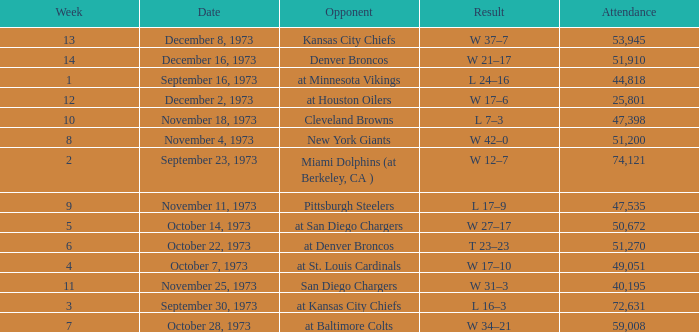Parse the full table. {'header': ['Week', 'Date', 'Opponent', 'Result', 'Attendance'], 'rows': [['13', 'December 8, 1973', 'Kansas City Chiefs', 'W 37–7', '53,945'], ['14', 'December 16, 1973', 'Denver Broncos', 'W 21–17', '51,910'], ['1', 'September 16, 1973', 'at Minnesota Vikings', 'L 24–16', '44,818'], ['12', 'December 2, 1973', 'at Houston Oilers', 'W 17–6', '25,801'], ['10', 'November 18, 1973', 'Cleveland Browns', 'L 7–3', '47,398'], ['8', 'November 4, 1973', 'New York Giants', 'W 42–0', '51,200'], ['2', 'September 23, 1973', 'Miami Dolphins (at Berkeley, CA )', 'W 12–7', '74,121'], ['9', 'November 11, 1973', 'Pittsburgh Steelers', 'L 17–9', '47,535'], ['5', 'October 14, 1973', 'at San Diego Chargers', 'W 27–17', '50,672'], ['6', 'October 22, 1973', 'at Denver Broncos', 'T 23–23', '51,270'], ['4', 'October 7, 1973', 'at St. Louis Cardinals', 'W 17–10', '49,051'], ['11', 'November 25, 1973', 'San Diego Chargers', 'W 31–3', '40,195'], ['3', 'September 30, 1973', 'at Kansas City Chiefs', 'L 16–3', '72,631'], ['7', 'October 28, 1973', 'at Baltimore Colts', 'W 34–21', '59,008']]} What is the attendance for the game against the Kansas City Chiefs earlier than week 13? None. 